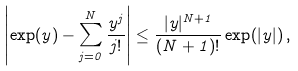Convert formula to latex. <formula><loc_0><loc_0><loc_500><loc_500>\left | \exp ( y ) - \sum _ { j = 0 } ^ { N } \frac { y ^ { j } } { j ! } \right | \leq \frac { | y | ^ { N + 1 } } { ( N + 1 ) ! } \exp ( | y | ) \, ,</formula> 